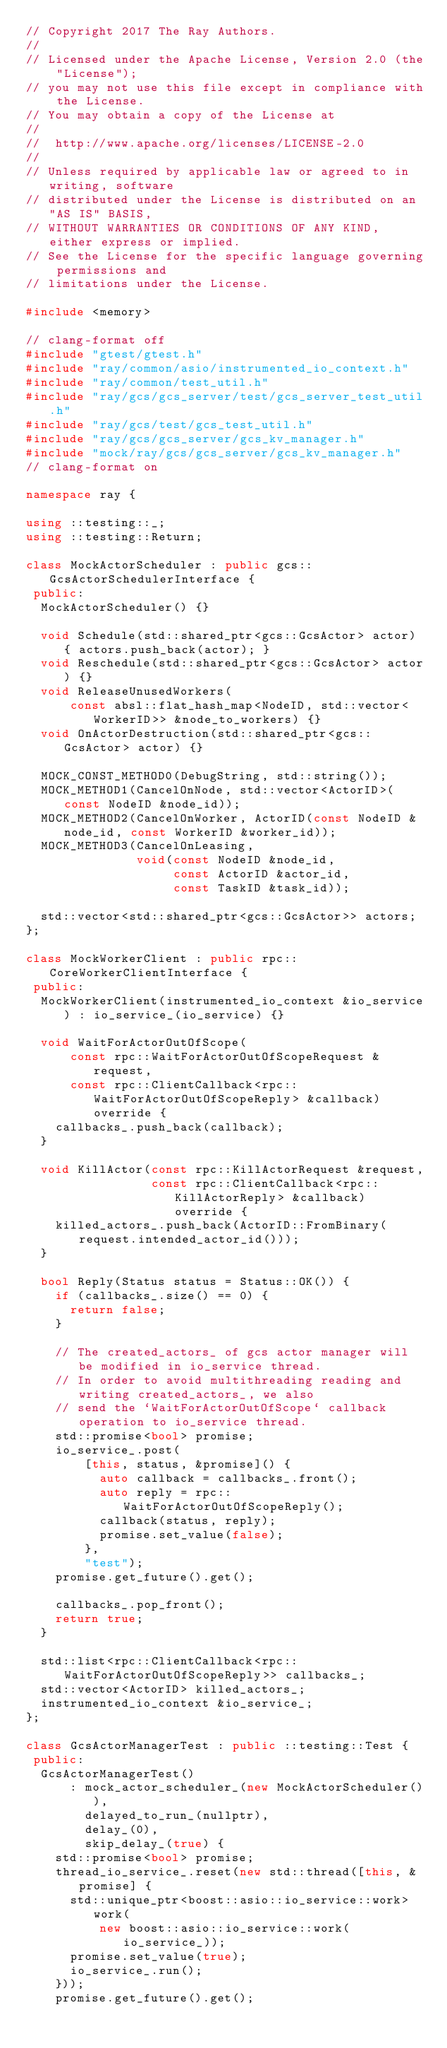Convert code to text. <code><loc_0><loc_0><loc_500><loc_500><_C++_>// Copyright 2017 The Ray Authors.
//
// Licensed under the Apache License, Version 2.0 (the "License");
// you may not use this file except in compliance with the License.
// You may obtain a copy of the License at
//
//  http://www.apache.org/licenses/LICENSE-2.0
//
// Unless required by applicable law or agreed to in writing, software
// distributed under the License is distributed on an "AS IS" BASIS,
// WITHOUT WARRANTIES OR CONDITIONS OF ANY KIND, either express or implied.
// See the License for the specific language governing permissions and
// limitations under the License.

#include <memory>

// clang-format off
#include "gtest/gtest.h"
#include "ray/common/asio/instrumented_io_context.h"
#include "ray/common/test_util.h"
#include "ray/gcs/gcs_server/test/gcs_server_test_util.h"
#include "ray/gcs/test/gcs_test_util.h"
#include "ray/gcs/gcs_server/gcs_kv_manager.h"
#include "mock/ray/gcs/gcs_server/gcs_kv_manager.h"
// clang-format on

namespace ray {

using ::testing::_;
using ::testing::Return;

class MockActorScheduler : public gcs::GcsActorSchedulerInterface {
 public:
  MockActorScheduler() {}

  void Schedule(std::shared_ptr<gcs::GcsActor> actor) { actors.push_back(actor); }
  void Reschedule(std::shared_ptr<gcs::GcsActor> actor) {}
  void ReleaseUnusedWorkers(
      const absl::flat_hash_map<NodeID, std::vector<WorkerID>> &node_to_workers) {}
  void OnActorDestruction(std::shared_ptr<gcs::GcsActor> actor) {}

  MOCK_CONST_METHOD0(DebugString, std::string());
  MOCK_METHOD1(CancelOnNode, std::vector<ActorID>(const NodeID &node_id));
  MOCK_METHOD2(CancelOnWorker, ActorID(const NodeID &node_id, const WorkerID &worker_id));
  MOCK_METHOD3(CancelOnLeasing,
               void(const NodeID &node_id,
                    const ActorID &actor_id,
                    const TaskID &task_id));

  std::vector<std::shared_ptr<gcs::GcsActor>> actors;
};

class MockWorkerClient : public rpc::CoreWorkerClientInterface {
 public:
  MockWorkerClient(instrumented_io_context &io_service) : io_service_(io_service) {}

  void WaitForActorOutOfScope(
      const rpc::WaitForActorOutOfScopeRequest &request,
      const rpc::ClientCallback<rpc::WaitForActorOutOfScopeReply> &callback) override {
    callbacks_.push_back(callback);
  }

  void KillActor(const rpc::KillActorRequest &request,
                 const rpc::ClientCallback<rpc::KillActorReply> &callback) override {
    killed_actors_.push_back(ActorID::FromBinary(request.intended_actor_id()));
  }

  bool Reply(Status status = Status::OK()) {
    if (callbacks_.size() == 0) {
      return false;
    }

    // The created_actors_ of gcs actor manager will be modified in io_service thread.
    // In order to avoid multithreading reading and writing created_actors_, we also
    // send the `WaitForActorOutOfScope` callback operation to io_service thread.
    std::promise<bool> promise;
    io_service_.post(
        [this, status, &promise]() {
          auto callback = callbacks_.front();
          auto reply = rpc::WaitForActorOutOfScopeReply();
          callback(status, reply);
          promise.set_value(false);
        },
        "test");
    promise.get_future().get();

    callbacks_.pop_front();
    return true;
  }

  std::list<rpc::ClientCallback<rpc::WaitForActorOutOfScopeReply>> callbacks_;
  std::vector<ActorID> killed_actors_;
  instrumented_io_context &io_service_;
};

class GcsActorManagerTest : public ::testing::Test {
 public:
  GcsActorManagerTest()
      : mock_actor_scheduler_(new MockActorScheduler()),
        delayed_to_run_(nullptr),
        delay_(0),
        skip_delay_(true) {
    std::promise<bool> promise;
    thread_io_service_.reset(new std::thread([this, &promise] {
      std::unique_ptr<boost::asio::io_service::work> work(
          new boost::asio::io_service::work(io_service_));
      promise.set_value(true);
      io_service_.run();
    }));
    promise.get_future().get();</code> 